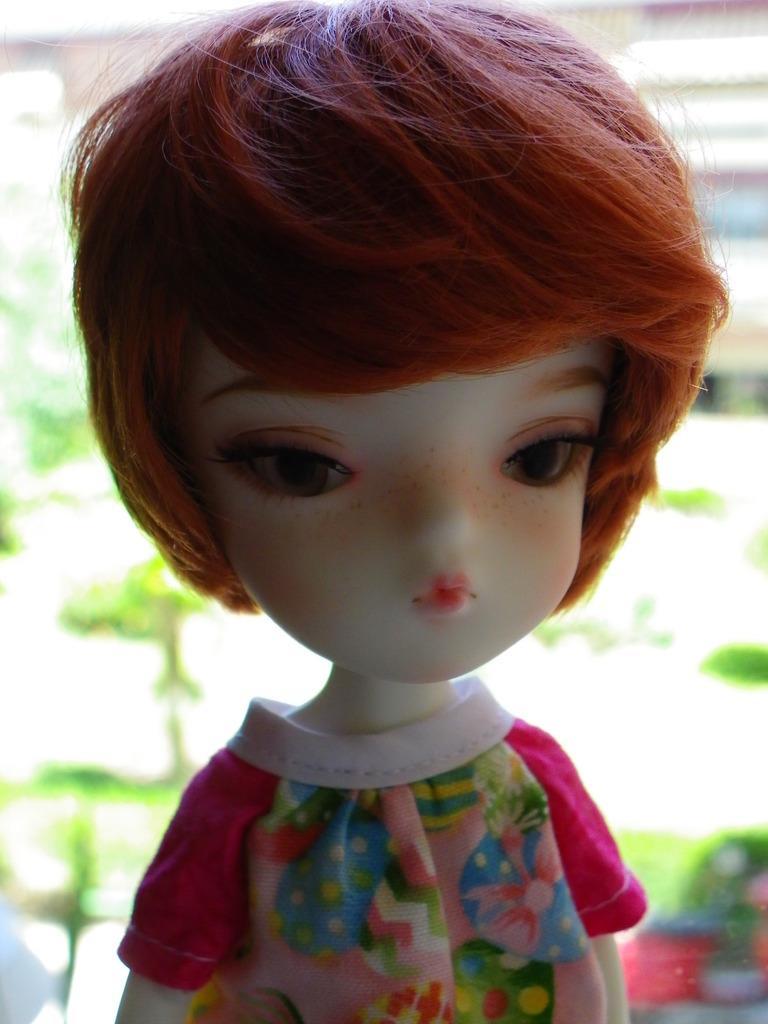Can you describe this image briefly? In front of the picture, we see a doll in a pink dress. In the background, we see trees and buildings. This picture is blurred in the background. 